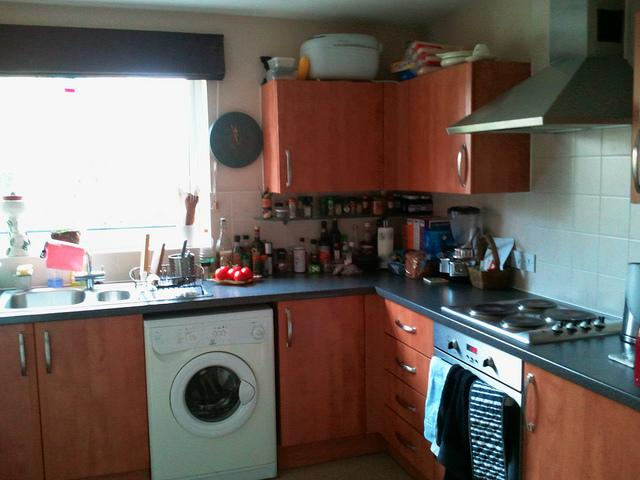What material is the sink made of? Please explain your reasoning. stainless steel. It is a shiny silver metal. 